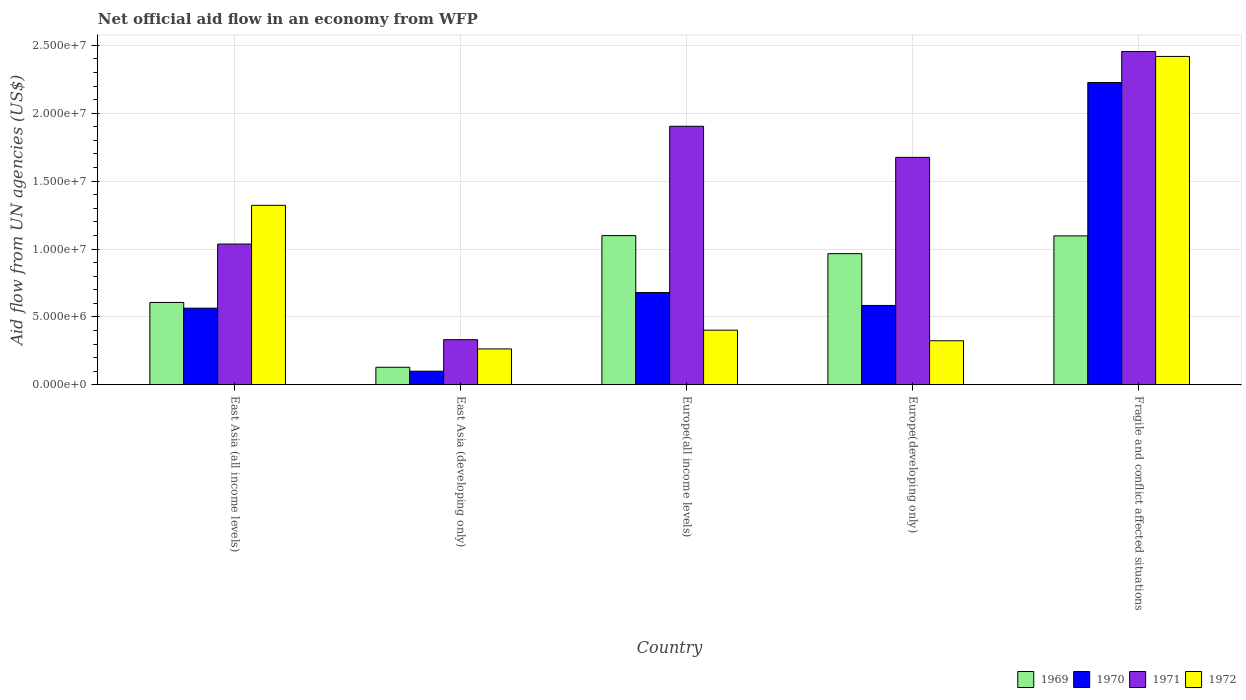How many groups of bars are there?
Your answer should be compact. 5. Are the number of bars per tick equal to the number of legend labels?
Provide a succinct answer. Yes. Are the number of bars on each tick of the X-axis equal?
Provide a short and direct response. Yes. What is the label of the 5th group of bars from the left?
Provide a succinct answer. Fragile and conflict affected situations. What is the net official aid flow in 1971 in Fragile and conflict affected situations?
Ensure brevity in your answer.  2.45e+07. Across all countries, what is the maximum net official aid flow in 1971?
Provide a succinct answer. 2.45e+07. Across all countries, what is the minimum net official aid flow in 1972?
Offer a terse response. 2.65e+06. In which country was the net official aid flow in 1971 maximum?
Provide a short and direct response. Fragile and conflict affected situations. In which country was the net official aid flow in 1971 minimum?
Keep it short and to the point. East Asia (developing only). What is the total net official aid flow in 1970 in the graph?
Your answer should be very brief. 4.16e+07. What is the difference between the net official aid flow in 1971 in East Asia (all income levels) and that in Europe(all income levels)?
Keep it short and to the point. -8.67e+06. What is the difference between the net official aid flow in 1972 in Europe(developing only) and the net official aid flow in 1970 in East Asia (developing only)?
Ensure brevity in your answer.  2.24e+06. What is the average net official aid flow in 1971 per country?
Give a very brief answer. 1.48e+07. What is the difference between the net official aid flow of/in 1970 and net official aid flow of/in 1972 in Fragile and conflict affected situations?
Keep it short and to the point. -1.92e+06. In how many countries, is the net official aid flow in 1969 greater than 8000000 US$?
Give a very brief answer. 3. What is the ratio of the net official aid flow in 1971 in Europe(all income levels) to that in Fragile and conflict affected situations?
Offer a terse response. 0.78. Is the difference between the net official aid flow in 1970 in East Asia (developing only) and Europe(all income levels) greater than the difference between the net official aid flow in 1972 in East Asia (developing only) and Europe(all income levels)?
Ensure brevity in your answer.  No. What is the difference between the highest and the second highest net official aid flow in 1971?
Your response must be concise. 5.50e+06. What is the difference between the highest and the lowest net official aid flow in 1971?
Give a very brief answer. 2.12e+07. In how many countries, is the net official aid flow in 1969 greater than the average net official aid flow in 1969 taken over all countries?
Your response must be concise. 3. Is it the case that in every country, the sum of the net official aid flow in 1971 and net official aid flow in 1972 is greater than the sum of net official aid flow in 1970 and net official aid flow in 1969?
Keep it short and to the point. No. What does the 4th bar from the right in East Asia (all income levels) represents?
Provide a succinct answer. 1969. Are all the bars in the graph horizontal?
Provide a succinct answer. No. How many countries are there in the graph?
Offer a very short reply. 5. Where does the legend appear in the graph?
Make the answer very short. Bottom right. What is the title of the graph?
Make the answer very short. Net official aid flow in an economy from WFP. Does "1987" appear as one of the legend labels in the graph?
Give a very brief answer. No. What is the label or title of the Y-axis?
Your answer should be compact. Aid flow from UN agencies (US$). What is the Aid flow from UN agencies (US$) of 1969 in East Asia (all income levels)?
Make the answer very short. 6.07e+06. What is the Aid flow from UN agencies (US$) in 1970 in East Asia (all income levels)?
Your answer should be compact. 5.65e+06. What is the Aid flow from UN agencies (US$) in 1971 in East Asia (all income levels)?
Offer a very short reply. 1.04e+07. What is the Aid flow from UN agencies (US$) of 1972 in East Asia (all income levels)?
Your answer should be very brief. 1.32e+07. What is the Aid flow from UN agencies (US$) in 1969 in East Asia (developing only)?
Offer a terse response. 1.30e+06. What is the Aid flow from UN agencies (US$) of 1970 in East Asia (developing only)?
Give a very brief answer. 1.01e+06. What is the Aid flow from UN agencies (US$) in 1971 in East Asia (developing only)?
Provide a short and direct response. 3.33e+06. What is the Aid flow from UN agencies (US$) in 1972 in East Asia (developing only)?
Your answer should be compact. 2.65e+06. What is the Aid flow from UN agencies (US$) in 1969 in Europe(all income levels)?
Your answer should be compact. 1.10e+07. What is the Aid flow from UN agencies (US$) of 1970 in Europe(all income levels)?
Give a very brief answer. 6.80e+06. What is the Aid flow from UN agencies (US$) of 1971 in Europe(all income levels)?
Provide a short and direct response. 1.90e+07. What is the Aid flow from UN agencies (US$) of 1972 in Europe(all income levels)?
Offer a terse response. 4.03e+06. What is the Aid flow from UN agencies (US$) in 1969 in Europe(developing only)?
Your answer should be very brief. 9.66e+06. What is the Aid flow from UN agencies (US$) in 1970 in Europe(developing only)?
Make the answer very short. 5.85e+06. What is the Aid flow from UN agencies (US$) in 1971 in Europe(developing only)?
Provide a succinct answer. 1.68e+07. What is the Aid flow from UN agencies (US$) in 1972 in Europe(developing only)?
Provide a succinct answer. 3.25e+06. What is the Aid flow from UN agencies (US$) in 1969 in Fragile and conflict affected situations?
Give a very brief answer. 1.10e+07. What is the Aid flow from UN agencies (US$) of 1970 in Fragile and conflict affected situations?
Keep it short and to the point. 2.23e+07. What is the Aid flow from UN agencies (US$) in 1971 in Fragile and conflict affected situations?
Your answer should be very brief. 2.45e+07. What is the Aid flow from UN agencies (US$) of 1972 in Fragile and conflict affected situations?
Offer a terse response. 2.42e+07. Across all countries, what is the maximum Aid flow from UN agencies (US$) in 1969?
Provide a short and direct response. 1.10e+07. Across all countries, what is the maximum Aid flow from UN agencies (US$) of 1970?
Provide a succinct answer. 2.23e+07. Across all countries, what is the maximum Aid flow from UN agencies (US$) of 1971?
Offer a very short reply. 2.45e+07. Across all countries, what is the maximum Aid flow from UN agencies (US$) in 1972?
Offer a terse response. 2.42e+07. Across all countries, what is the minimum Aid flow from UN agencies (US$) in 1969?
Provide a short and direct response. 1.30e+06. Across all countries, what is the minimum Aid flow from UN agencies (US$) of 1970?
Keep it short and to the point. 1.01e+06. Across all countries, what is the minimum Aid flow from UN agencies (US$) in 1971?
Your answer should be very brief. 3.33e+06. Across all countries, what is the minimum Aid flow from UN agencies (US$) of 1972?
Offer a terse response. 2.65e+06. What is the total Aid flow from UN agencies (US$) in 1969 in the graph?
Make the answer very short. 3.90e+07. What is the total Aid flow from UN agencies (US$) in 1970 in the graph?
Ensure brevity in your answer.  4.16e+07. What is the total Aid flow from UN agencies (US$) in 1971 in the graph?
Your answer should be very brief. 7.40e+07. What is the total Aid flow from UN agencies (US$) of 1972 in the graph?
Offer a very short reply. 4.73e+07. What is the difference between the Aid flow from UN agencies (US$) in 1969 in East Asia (all income levels) and that in East Asia (developing only)?
Your answer should be very brief. 4.77e+06. What is the difference between the Aid flow from UN agencies (US$) in 1970 in East Asia (all income levels) and that in East Asia (developing only)?
Keep it short and to the point. 4.64e+06. What is the difference between the Aid flow from UN agencies (US$) of 1971 in East Asia (all income levels) and that in East Asia (developing only)?
Provide a succinct answer. 7.04e+06. What is the difference between the Aid flow from UN agencies (US$) of 1972 in East Asia (all income levels) and that in East Asia (developing only)?
Your answer should be compact. 1.06e+07. What is the difference between the Aid flow from UN agencies (US$) in 1969 in East Asia (all income levels) and that in Europe(all income levels)?
Offer a terse response. -4.92e+06. What is the difference between the Aid flow from UN agencies (US$) in 1970 in East Asia (all income levels) and that in Europe(all income levels)?
Keep it short and to the point. -1.15e+06. What is the difference between the Aid flow from UN agencies (US$) in 1971 in East Asia (all income levels) and that in Europe(all income levels)?
Ensure brevity in your answer.  -8.67e+06. What is the difference between the Aid flow from UN agencies (US$) of 1972 in East Asia (all income levels) and that in Europe(all income levels)?
Your response must be concise. 9.19e+06. What is the difference between the Aid flow from UN agencies (US$) in 1969 in East Asia (all income levels) and that in Europe(developing only)?
Keep it short and to the point. -3.59e+06. What is the difference between the Aid flow from UN agencies (US$) of 1971 in East Asia (all income levels) and that in Europe(developing only)?
Make the answer very short. -6.38e+06. What is the difference between the Aid flow from UN agencies (US$) in 1972 in East Asia (all income levels) and that in Europe(developing only)?
Provide a succinct answer. 9.97e+06. What is the difference between the Aid flow from UN agencies (US$) of 1969 in East Asia (all income levels) and that in Fragile and conflict affected situations?
Provide a short and direct response. -4.90e+06. What is the difference between the Aid flow from UN agencies (US$) of 1970 in East Asia (all income levels) and that in Fragile and conflict affected situations?
Your answer should be very brief. -1.66e+07. What is the difference between the Aid flow from UN agencies (US$) in 1971 in East Asia (all income levels) and that in Fragile and conflict affected situations?
Offer a very short reply. -1.42e+07. What is the difference between the Aid flow from UN agencies (US$) in 1972 in East Asia (all income levels) and that in Fragile and conflict affected situations?
Your answer should be very brief. -1.10e+07. What is the difference between the Aid flow from UN agencies (US$) in 1969 in East Asia (developing only) and that in Europe(all income levels)?
Make the answer very short. -9.69e+06. What is the difference between the Aid flow from UN agencies (US$) in 1970 in East Asia (developing only) and that in Europe(all income levels)?
Provide a short and direct response. -5.79e+06. What is the difference between the Aid flow from UN agencies (US$) of 1971 in East Asia (developing only) and that in Europe(all income levels)?
Keep it short and to the point. -1.57e+07. What is the difference between the Aid flow from UN agencies (US$) in 1972 in East Asia (developing only) and that in Europe(all income levels)?
Offer a very short reply. -1.38e+06. What is the difference between the Aid flow from UN agencies (US$) of 1969 in East Asia (developing only) and that in Europe(developing only)?
Ensure brevity in your answer.  -8.36e+06. What is the difference between the Aid flow from UN agencies (US$) in 1970 in East Asia (developing only) and that in Europe(developing only)?
Make the answer very short. -4.84e+06. What is the difference between the Aid flow from UN agencies (US$) in 1971 in East Asia (developing only) and that in Europe(developing only)?
Offer a very short reply. -1.34e+07. What is the difference between the Aid flow from UN agencies (US$) of 1972 in East Asia (developing only) and that in Europe(developing only)?
Your response must be concise. -6.00e+05. What is the difference between the Aid flow from UN agencies (US$) in 1969 in East Asia (developing only) and that in Fragile and conflict affected situations?
Give a very brief answer. -9.67e+06. What is the difference between the Aid flow from UN agencies (US$) of 1970 in East Asia (developing only) and that in Fragile and conflict affected situations?
Provide a short and direct response. -2.12e+07. What is the difference between the Aid flow from UN agencies (US$) of 1971 in East Asia (developing only) and that in Fragile and conflict affected situations?
Provide a short and direct response. -2.12e+07. What is the difference between the Aid flow from UN agencies (US$) of 1972 in East Asia (developing only) and that in Fragile and conflict affected situations?
Your answer should be compact. -2.15e+07. What is the difference between the Aid flow from UN agencies (US$) in 1969 in Europe(all income levels) and that in Europe(developing only)?
Give a very brief answer. 1.33e+06. What is the difference between the Aid flow from UN agencies (US$) of 1970 in Europe(all income levels) and that in Europe(developing only)?
Provide a short and direct response. 9.50e+05. What is the difference between the Aid flow from UN agencies (US$) of 1971 in Europe(all income levels) and that in Europe(developing only)?
Ensure brevity in your answer.  2.29e+06. What is the difference between the Aid flow from UN agencies (US$) in 1972 in Europe(all income levels) and that in Europe(developing only)?
Your answer should be very brief. 7.80e+05. What is the difference between the Aid flow from UN agencies (US$) of 1970 in Europe(all income levels) and that in Fragile and conflict affected situations?
Provide a short and direct response. -1.55e+07. What is the difference between the Aid flow from UN agencies (US$) of 1971 in Europe(all income levels) and that in Fragile and conflict affected situations?
Provide a succinct answer. -5.50e+06. What is the difference between the Aid flow from UN agencies (US$) of 1972 in Europe(all income levels) and that in Fragile and conflict affected situations?
Keep it short and to the point. -2.02e+07. What is the difference between the Aid flow from UN agencies (US$) of 1969 in Europe(developing only) and that in Fragile and conflict affected situations?
Provide a short and direct response. -1.31e+06. What is the difference between the Aid flow from UN agencies (US$) of 1970 in Europe(developing only) and that in Fragile and conflict affected situations?
Ensure brevity in your answer.  -1.64e+07. What is the difference between the Aid flow from UN agencies (US$) in 1971 in Europe(developing only) and that in Fragile and conflict affected situations?
Ensure brevity in your answer.  -7.79e+06. What is the difference between the Aid flow from UN agencies (US$) of 1972 in Europe(developing only) and that in Fragile and conflict affected situations?
Make the answer very short. -2.09e+07. What is the difference between the Aid flow from UN agencies (US$) of 1969 in East Asia (all income levels) and the Aid flow from UN agencies (US$) of 1970 in East Asia (developing only)?
Provide a succinct answer. 5.06e+06. What is the difference between the Aid flow from UN agencies (US$) of 1969 in East Asia (all income levels) and the Aid flow from UN agencies (US$) of 1971 in East Asia (developing only)?
Give a very brief answer. 2.74e+06. What is the difference between the Aid flow from UN agencies (US$) in 1969 in East Asia (all income levels) and the Aid flow from UN agencies (US$) in 1972 in East Asia (developing only)?
Keep it short and to the point. 3.42e+06. What is the difference between the Aid flow from UN agencies (US$) of 1970 in East Asia (all income levels) and the Aid flow from UN agencies (US$) of 1971 in East Asia (developing only)?
Your answer should be compact. 2.32e+06. What is the difference between the Aid flow from UN agencies (US$) of 1970 in East Asia (all income levels) and the Aid flow from UN agencies (US$) of 1972 in East Asia (developing only)?
Your response must be concise. 3.00e+06. What is the difference between the Aid flow from UN agencies (US$) in 1971 in East Asia (all income levels) and the Aid flow from UN agencies (US$) in 1972 in East Asia (developing only)?
Provide a succinct answer. 7.72e+06. What is the difference between the Aid flow from UN agencies (US$) of 1969 in East Asia (all income levels) and the Aid flow from UN agencies (US$) of 1970 in Europe(all income levels)?
Your response must be concise. -7.30e+05. What is the difference between the Aid flow from UN agencies (US$) of 1969 in East Asia (all income levels) and the Aid flow from UN agencies (US$) of 1971 in Europe(all income levels)?
Keep it short and to the point. -1.30e+07. What is the difference between the Aid flow from UN agencies (US$) in 1969 in East Asia (all income levels) and the Aid flow from UN agencies (US$) in 1972 in Europe(all income levels)?
Offer a terse response. 2.04e+06. What is the difference between the Aid flow from UN agencies (US$) in 1970 in East Asia (all income levels) and the Aid flow from UN agencies (US$) in 1971 in Europe(all income levels)?
Offer a very short reply. -1.34e+07. What is the difference between the Aid flow from UN agencies (US$) of 1970 in East Asia (all income levels) and the Aid flow from UN agencies (US$) of 1972 in Europe(all income levels)?
Give a very brief answer. 1.62e+06. What is the difference between the Aid flow from UN agencies (US$) of 1971 in East Asia (all income levels) and the Aid flow from UN agencies (US$) of 1972 in Europe(all income levels)?
Offer a terse response. 6.34e+06. What is the difference between the Aid flow from UN agencies (US$) of 1969 in East Asia (all income levels) and the Aid flow from UN agencies (US$) of 1970 in Europe(developing only)?
Ensure brevity in your answer.  2.20e+05. What is the difference between the Aid flow from UN agencies (US$) of 1969 in East Asia (all income levels) and the Aid flow from UN agencies (US$) of 1971 in Europe(developing only)?
Provide a succinct answer. -1.07e+07. What is the difference between the Aid flow from UN agencies (US$) of 1969 in East Asia (all income levels) and the Aid flow from UN agencies (US$) of 1972 in Europe(developing only)?
Your answer should be very brief. 2.82e+06. What is the difference between the Aid flow from UN agencies (US$) of 1970 in East Asia (all income levels) and the Aid flow from UN agencies (US$) of 1971 in Europe(developing only)?
Make the answer very short. -1.11e+07. What is the difference between the Aid flow from UN agencies (US$) of 1970 in East Asia (all income levels) and the Aid flow from UN agencies (US$) of 1972 in Europe(developing only)?
Give a very brief answer. 2.40e+06. What is the difference between the Aid flow from UN agencies (US$) of 1971 in East Asia (all income levels) and the Aid flow from UN agencies (US$) of 1972 in Europe(developing only)?
Your answer should be very brief. 7.12e+06. What is the difference between the Aid flow from UN agencies (US$) in 1969 in East Asia (all income levels) and the Aid flow from UN agencies (US$) in 1970 in Fragile and conflict affected situations?
Offer a terse response. -1.62e+07. What is the difference between the Aid flow from UN agencies (US$) of 1969 in East Asia (all income levels) and the Aid flow from UN agencies (US$) of 1971 in Fragile and conflict affected situations?
Ensure brevity in your answer.  -1.85e+07. What is the difference between the Aid flow from UN agencies (US$) in 1969 in East Asia (all income levels) and the Aid flow from UN agencies (US$) in 1972 in Fragile and conflict affected situations?
Your response must be concise. -1.81e+07. What is the difference between the Aid flow from UN agencies (US$) in 1970 in East Asia (all income levels) and the Aid flow from UN agencies (US$) in 1971 in Fragile and conflict affected situations?
Your response must be concise. -1.89e+07. What is the difference between the Aid flow from UN agencies (US$) of 1970 in East Asia (all income levels) and the Aid flow from UN agencies (US$) of 1972 in Fragile and conflict affected situations?
Offer a very short reply. -1.85e+07. What is the difference between the Aid flow from UN agencies (US$) of 1971 in East Asia (all income levels) and the Aid flow from UN agencies (US$) of 1972 in Fragile and conflict affected situations?
Your response must be concise. -1.38e+07. What is the difference between the Aid flow from UN agencies (US$) of 1969 in East Asia (developing only) and the Aid flow from UN agencies (US$) of 1970 in Europe(all income levels)?
Your answer should be compact. -5.50e+06. What is the difference between the Aid flow from UN agencies (US$) of 1969 in East Asia (developing only) and the Aid flow from UN agencies (US$) of 1971 in Europe(all income levels)?
Provide a succinct answer. -1.77e+07. What is the difference between the Aid flow from UN agencies (US$) of 1969 in East Asia (developing only) and the Aid flow from UN agencies (US$) of 1972 in Europe(all income levels)?
Your response must be concise. -2.73e+06. What is the difference between the Aid flow from UN agencies (US$) in 1970 in East Asia (developing only) and the Aid flow from UN agencies (US$) in 1971 in Europe(all income levels)?
Ensure brevity in your answer.  -1.80e+07. What is the difference between the Aid flow from UN agencies (US$) of 1970 in East Asia (developing only) and the Aid flow from UN agencies (US$) of 1972 in Europe(all income levels)?
Keep it short and to the point. -3.02e+06. What is the difference between the Aid flow from UN agencies (US$) of 1971 in East Asia (developing only) and the Aid flow from UN agencies (US$) of 1972 in Europe(all income levels)?
Give a very brief answer. -7.00e+05. What is the difference between the Aid flow from UN agencies (US$) in 1969 in East Asia (developing only) and the Aid flow from UN agencies (US$) in 1970 in Europe(developing only)?
Offer a very short reply. -4.55e+06. What is the difference between the Aid flow from UN agencies (US$) of 1969 in East Asia (developing only) and the Aid flow from UN agencies (US$) of 1971 in Europe(developing only)?
Provide a succinct answer. -1.54e+07. What is the difference between the Aid flow from UN agencies (US$) in 1969 in East Asia (developing only) and the Aid flow from UN agencies (US$) in 1972 in Europe(developing only)?
Provide a succinct answer. -1.95e+06. What is the difference between the Aid flow from UN agencies (US$) of 1970 in East Asia (developing only) and the Aid flow from UN agencies (US$) of 1971 in Europe(developing only)?
Your response must be concise. -1.57e+07. What is the difference between the Aid flow from UN agencies (US$) of 1970 in East Asia (developing only) and the Aid flow from UN agencies (US$) of 1972 in Europe(developing only)?
Offer a very short reply. -2.24e+06. What is the difference between the Aid flow from UN agencies (US$) of 1971 in East Asia (developing only) and the Aid flow from UN agencies (US$) of 1972 in Europe(developing only)?
Your answer should be very brief. 8.00e+04. What is the difference between the Aid flow from UN agencies (US$) in 1969 in East Asia (developing only) and the Aid flow from UN agencies (US$) in 1970 in Fragile and conflict affected situations?
Provide a succinct answer. -2.10e+07. What is the difference between the Aid flow from UN agencies (US$) in 1969 in East Asia (developing only) and the Aid flow from UN agencies (US$) in 1971 in Fragile and conflict affected situations?
Ensure brevity in your answer.  -2.32e+07. What is the difference between the Aid flow from UN agencies (US$) in 1969 in East Asia (developing only) and the Aid flow from UN agencies (US$) in 1972 in Fragile and conflict affected situations?
Your response must be concise. -2.29e+07. What is the difference between the Aid flow from UN agencies (US$) of 1970 in East Asia (developing only) and the Aid flow from UN agencies (US$) of 1971 in Fragile and conflict affected situations?
Provide a succinct answer. -2.35e+07. What is the difference between the Aid flow from UN agencies (US$) in 1970 in East Asia (developing only) and the Aid flow from UN agencies (US$) in 1972 in Fragile and conflict affected situations?
Offer a very short reply. -2.32e+07. What is the difference between the Aid flow from UN agencies (US$) in 1971 in East Asia (developing only) and the Aid flow from UN agencies (US$) in 1972 in Fragile and conflict affected situations?
Your answer should be very brief. -2.08e+07. What is the difference between the Aid flow from UN agencies (US$) of 1969 in Europe(all income levels) and the Aid flow from UN agencies (US$) of 1970 in Europe(developing only)?
Provide a succinct answer. 5.14e+06. What is the difference between the Aid flow from UN agencies (US$) of 1969 in Europe(all income levels) and the Aid flow from UN agencies (US$) of 1971 in Europe(developing only)?
Keep it short and to the point. -5.76e+06. What is the difference between the Aid flow from UN agencies (US$) in 1969 in Europe(all income levels) and the Aid flow from UN agencies (US$) in 1972 in Europe(developing only)?
Keep it short and to the point. 7.74e+06. What is the difference between the Aid flow from UN agencies (US$) of 1970 in Europe(all income levels) and the Aid flow from UN agencies (US$) of 1971 in Europe(developing only)?
Make the answer very short. -9.95e+06. What is the difference between the Aid flow from UN agencies (US$) in 1970 in Europe(all income levels) and the Aid flow from UN agencies (US$) in 1972 in Europe(developing only)?
Provide a succinct answer. 3.55e+06. What is the difference between the Aid flow from UN agencies (US$) in 1971 in Europe(all income levels) and the Aid flow from UN agencies (US$) in 1972 in Europe(developing only)?
Provide a short and direct response. 1.58e+07. What is the difference between the Aid flow from UN agencies (US$) in 1969 in Europe(all income levels) and the Aid flow from UN agencies (US$) in 1970 in Fragile and conflict affected situations?
Your response must be concise. -1.13e+07. What is the difference between the Aid flow from UN agencies (US$) of 1969 in Europe(all income levels) and the Aid flow from UN agencies (US$) of 1971 in Fragile and conflict affected situations?
Provide a succinct answer. -1.36e+07. What is the difference between the Aid flow from UN agencies (US$) of 1969 in Europe(all income levels) and the Aid flow from UN agencies (US$) of 1972 in Fragile and conflict affected situations?
Your answer should be very brief. -1.32e+07. What is the difference between the Aid flow from UN agencies (US$) in 1970 in Europe(all income levels) and the Aid flow from UN agencies (US$) in 1971 in Fragile and conflict affected situations?
Provide a succinct answer. -1.77e+07. What is the difference between the Aid flow from UN agencies (US$) of 1970 in Europe(all income levels) and the Aid flow from UN agencies (US$) of 1972 in Fragile and conflict affected situations?
Provide a short and direct response. -1.74e+07. What is the difference between the Aid flow from UN agencies (US$) of 1971 in Europe(all income levels) and the Aid flow from UN agencies (US$) of 1972 in Fragile and conflict affected situations?
Your answer should be compact. -5.14e+06. What is the difference between the Aid flow from UN agencies (US$) of 1969 in Europe(developing only) and the Aid flow from UN agencies (US$) of 1970 in Fragile and conflict affected situations?
Offer a terse response. -1.26e+07. What is the difference between the Aid flow from UN agencies (US$) of 1969 in Europe(developing only) and the Aid flow from UN agencies (US$) of 1971 in Fragile and conflict affected situations?
Provide a succinct answer. -1.49e+07. What is the difference between the Aid flow from UN agencies (US$) of 1969 in Europe(developing only) and the Aid flow from UN agencies (US$) of 1972 in Fragile and conflict affected situations?
Your answer should be very brief. -1.45e+07. What is the difference between the Aid flow from UN agencies (US$) of 1970 in Europe(developing only) and the Aid flow from UN agencies (US$) of 1971 in Fragile and conflict affected situations?
Provide a succinct answer. -1.87e+07. What is the difference between the Aid flow from UN agencies (US$) of 1970 in Europe(developing only) and the Aid flow from UN agencies (US$) of 1972 in Fragile and conflict affected situations?
Your response must be concise. -1.83e+07. What is the difference between the Aid flow from UN agencies (US$) of 1971 in Europe(developing only) and the Aid flow from UN agencies (US$) of 1972 in Fragile and conflict affected situations?
Ensure brevity in your answer.  -7.43e+06. What is the average Aid flow from UN agencies (US$) of 1969 per country?
Make the answer very short. 7.80e+06. What is the average Aid flow from UN agencies (US$) in 1970 per country?
Make the answer very short. 8.31e+06. What is the average Aid flow from UN agencies (US$) of 1971 per country?
Make the answer very short. 1.48e+07. What is the average Aid flow from UN agencies (US$) of 1972 per country?
Your answer should be very brief. 9.47e+06. What is the difference between the Aid flow from UN agencies (US$) in 1969 and Aid flow from UN agencies (US$) in 1970 in East Asia (all income levels)?
Provide a short and direct response. 4.20e+05. What is the difference between the Aid flow from UN agencies (US$) in 1969 and Aid flow from UN agencies (US$) in 1971 in East Asia (all income levels)?
Offer a very short reply. -4.30e+06. What is the difference between the Aid flow from UN agencies (US$) of 1969 and Aid flow from UN agencies (US$) of 1972 in East Asia (all income levels)?
Make the answer very short. -7.15e+06. What is the difference between the Aid flow from UN agencies (US$) in 1970 and Aid flow from UN agencies (US$) in 1971 in East Asia (all income levels)?
Ensure brevity in your answer.  -4.72e+06. What is the difference between the Aid flow from UN agencies (US$) in 1970 and Aid flow from UN agencies (US$) in 1972 in East Asia (all income levels)?
Provide a succinct answer. -7.57e+06. What is the difference between the Aid flow from UN agencies (US$) in 1971 and Aid flow from UN agencies (US$) in 1972 in East Asia (all income levels)?
Offer a very short reply. -2.85e+06. What is the difference between the Aid flow from UN agencies (US$) in 1969 and Aid flow from UN agencies (US$) in 1970 in East Asia (developing only)?
Your answer should be compact. 2.90e+05. What is the difference between the Aid flow from UN agencies (US$) in 1969 and Aid flow from UN agencies (US$) in 1971 in East Asia (developing only)?
Offer a very short reply. -2.03e+06. What is the difference between the Aid flow from UN agencies (US$) of 1969 and Aid flow from UN agencies (US$) of 1972 in East Asia (developing only)?
Give a very brief answer. -1.35e+06. What is the difference between the Aid flow from UN agencies (US$) in 1970 and Aid flow from UN agencies (US$) in 1971 in East Asia (developing only)?
Offer a very short reply. -2.32e+06. What is the difference between the Aid flow from UN agencies (US$) in 1970 and Aid flow from UN agencies (US$) in 1972 in East Asia (developing only)?
Offer a very short reply. -1.64e+06. What is the difference between the Aid flow from UN agencies (US$) in 1971 and Aid flow from UN agencies (US$) in 1972 in East Asia (developing only)?
Make the answer very short. 6.80e+05. What is the difference between the Aid flow from UN agencies (US$) of 1969 and Aid flow from UN agencies (US$) of 1970 in Europe(all income levels)?
Ensure brevity in your answer.  4.19e+06. What is the difference between the Aid flow from UN agencies (US$) in 1969 and Aid flow from UN agencies (US$) in 1971 in Europe(all income levels)?
Provide a short and direct response. -8.05e+06. What is the difference between the Aid flow from UN agencies (US$) in 1969 and Aid flow from UN agencies (US$) in 1972 in Europe(all income levels)?
Give a very brief answer. 6.96e+06. What is the difference between the Aid flow from UN agencies (US$) in 1970 and Aid flow from UN agencies (US$) in 1971 in Europe(all income levels)?
Provide a succinct answer. -1.22e+07. What is the difference between the Aid flow from UN agencies (US$) in 1970 and Aid flow from UN agencies (US$) in 1972 in Europe(all income levels)?
Your answer should be compact. 2.77e+06. What is the difference between the Aid flow from UN agencies (US$) in 1971 and Aid flow from UN agencies (US$) in 1972 in Europe(all income levels)?
Provide a short and direct response. 1.50e+07. What is the difference between the Aid flow from UN agencies (US$) in 1969 and Aid flow from UN agencies (US$) in 1970 in Europe(developing only)?
Ensure brevity in your answer.  3.81e+06. What is the difference between the Aid flow from UN agencies (US$) of 1969 and Aid flow from UN agencies (US$) of 1971 in Europe(developing only)?
Your answer should be very brief. -7.09e+06. What is the difference between the Aid flow from UN agencies (US$) of 1969 and Aid flow from UN agencies (US$) of 1972 in Europe(developing only)?
Provide a succinct answer. 6.41e+06. What is the difference between the Aid flow from UN agencies (US$) of 1970 and Aid flow from UN agencies (US$) of 1971 in Europe(developing only)?
Ensure brevity in your answer.  -1.09e+07. What is the difference between the Aid flow from UN agencies (US$) in 1970 and Aid flow from UN agencies (US$) in 1972 in Europe(developing only)?
Your answer should be very brief. 2.60e+06. What is the difference between the Aid flow from UN agencies (US$) of 1971 and Aid flow from UN agencies (US$) of 1972 in Europe(developing only)?
Your response must be concise. 1.35e+07. What is the difference between the Aid flow from UN agencies (US$) in 1969 and Aid flow from UN agencies (US$) in 1970 in Fragile and conflict affected situations?
Keep it short and to the point. -1.13e+07. What is the difference between the Aid flow from UN agencies (US$) of 1969 and Aid flow from UN agencies (US$) of 1971 in Fragile and conflict affected situations?
Provide a short and direct response. -1.36e+07. What is the difference between the Aid flow from UN agencies (US$) in 1969 and Aid flow from UN agencies (US$) in 1972 in Fragile and conflict affected situations?
Provide a short and direct response. -1.32e+07. What is the difference between the Aid flow from UN agencies (US$) of 1970 and Aid flow from UN agencies (US$) of 1971 in Fragile and conflict affected situations?
Provide a succinct answer. -2.28e+06. What is the difference between the Aid flow from UN agencies (US$) in 1970 and Aid flow from UN agencies (US$) in 1972 in Fragile and conflict affected situations?
Offer a very short reply. -1.92e+06. What is the difference between the Aid flow from UN agencies (US$) of 1971 and Aid flow from UN agencies (US$) of 1972 in Fragile and conflict affected situations?
Offer a terse response. 3.60e+05. What is the ratio of the Aid flow from UN agencies (US$) of 1969 in East Asia (all income levels) to that in East Asia (developing only)?
Your response must be concise. 4.67. What is the ratio of the Aid flow from UN agencies (US$) in 1970 in East Asia (all income levels) to that in East Asia (developing only)?
Provide a succinct answer. 5.59. What is the ratio of the Aid flow from UN agencies (US$) of 1971 in East Asia (all income levels) to that in East Asia (developing only)?
Provide a succinct answer. 3.11. What is the ratio of the Aid flow from UN agencies (US$) in 1972 in East Asia (all income levels) to that in East Asia (developing only)?
Ensure brevity in your answer.  4.99. What is the ratio of the Aid flow from UN agencies (US$) in 1969 in East Asia (all income levels) to that in Europe(all income levels)?
Make the answer very short. 0.55. What is the ratio of the Aid flow from UN agencies (US$) of 1970 in East Asia (all income levels) to that in Europe(all income levels)?
Give a very brief answer. 0.83. What is the ratio of the Aid flow from UN agencies (US$) of 1971 in East Asia (all income levels) to that in Europe(all income levels)?
Offer a very short reply. 0.54. What is the ratio of the Aid flow from UN agencies (US$) of 1972 in East Asia (all income levels) to that in Europe(all income levels)?
Provide a succinct answer. 3.28. What is the ratio of the Aid flow from UN agencies (US$) of 1969 in East Asia (all income levels) to that in Europe(developing only)?
Provide a succinct answer. 0.63. What is the ratio of the Aid flow from UN agencies (US$) in 1970 in East Asia (all income levels) to that in Europe(developing only)?
Your answer should be compact. 0.97. What is the ratio of the Aid flow from UN agencies (US$) of 1971 in East Asia (all income levels) to that in Europe(developing only)?
Your answer should be compact. 0.62. What is the ratio of the Aid flow from UN agencies (US$) in 1972 in East Asia (all income levels) to that in Europe(developing only)?
Your answer should be compact. 4.07. What is the ratio of the Aid flow from UN agencies (US$) of 1969 in East Asia (all income levels) to that in Fragile and conflict affected situations?
Offer a very short reply. 0.55. What is the ratio of the Aid flow from UN agencies (US$) in 1970 in East Asia (all income levels) to that in Fragile and conflict affected situations?
Offer a very short reply. 0.25. What is the ratio of the Aid flow from UN agencies (US$) in 1971 in East Asia (all income levels) to that in Fragile and conflict affected situations?
Offer a terse response. 0.42. What is the ratio of the Aid flow from UN agencies (US$) of 1972 in East Asia (all income levels) to that in Fragile and conflict affected situations?
Give a very brief answer. 0.55. What is the ratio of the Aid flow from UN agencies (US$) in 1969 in East Asia (developing only) to that in Europe(all income levels)?
Make the answer very short. 0.12. What is the ratio of the Aid flow from UN agencies (US$) in 1970 in East Asia (developing only) to that in Europe(all income levels)?
Provide a short and direct response. 0.15. What is the ratio of the Aid flow from UN agencies (US$) in 1971 in East Asia (developing only) to that in Europe(all income levels)?
Provide a succinct answer. 0.17. What is the ratio of the Aid flow from UN agencies (US$) in 1972 in East Asia (developing only) to that in Europe(all income levels)?
Give a very brief answer. 0.66. What is the ratio of the Aid flow from UN agencies (US$) of 1969 in East Asia (developing only) to that in Europe(developing only)?
Your answer should be very brief. 0.13. What is the ratio of the Aid flow from UN agencies (US$) in 1970 in East Asia (developing only) to that in Europe(developing only)?
Offer a terse response. 0.17. What is the ratio of the Aid flow from UN agencies (US$) of 1971 in East Asia (developing only) to that in Europe(developing only)?
Offer a terse response. 0.2. What is the ratio of the Aid flow from UN agencies (US$) in 1972 in East Asia (developing only) to that in Europe(developing only)?
Offer a very short reply. 0.82. What is the ratio of the Aid flow from UN agencies (US$) in 1969 in East Asia (developing only) to that in Fragile and conflict affected situations?
Your answer should be very brief. 0.12. What is the ratio of the Aid flow from UN agencies (US$) in 1970 in East Asia (developing only) to that in Fragile and conflict affected situations?
Your response must be concise. 0.05. What is the ratio of the Aid flow from UN agencies (US$) of 1971 in East Asia (developing only) to that in Fragile and conflict affected situations?
Your answer should be very brief. 0.14. What is the ratio of the Aid flow from UN agencies (US$) of 1972 in East Asia (developing only) to that in Fragile and conflict affected situations?
Make the answer very short. 0.11. What is the ratio of the Aid flow from UN agencies (US$) in 1969 in Europe(all income levels) to that in Europe(developing only)?
Offer a terse response. 1.14. What is the ratio of the Aid flow from UN agencies (US$) in 1970 in Europe(all income levels) to that in Europe(developing only)?
Your answer should be compact. 1.16. What is the ratio of the Aid flow from UN agencies (US$) of 1971 in Europe(all income levels) to that in Europe(developing only)?
Provide a succinct answer. 1.14. What is the ratio of the Aid flow from UN agencies (US$) of 1972 in Europe(all income levels) to that in Europe(developing only)?
Offer a very short reply. 1.24. What is the ratio of the Aid flow from UN agencies (US$) in 1970 in Europe(all income levels) to that in Fragile and conflict affected situations?
Give a very brief answer. 0.31. What is the ratio of the Aid flow from UN agencies (US$) of 1971 in Europe(all income levels) to that in Fragile and conflict affected situations?
Ensure brevity in your answer.  0.78. What is the ratio of the Aid flow from UN agencies (US$) of 1969 in Europe(developing only) to that in Fragile and conflict affected situations?
Provide a succinct answer. 0.88. What is the ratio of the Aid flow from UN agencies (US$) of 1970 in Europe(developing only) to that in Fragile and conflict affected situations?
Provide a succinct answer. 0.26. What is the ratio of the Aid flow from UN agencies (US$) of 1971 in Europe(developing only) to that in Fragile and conflict affected situations?
Provide a short and direct response. 0.68. What is the ratio of the Aid flow from UN agencies (US$) in 1972 in Europe(developing only) to that in Fragile and conflict affected situations?
Provide a short and direct response. 0.13. What is the difference between the highest and the second highest Aid flow from UN agencies (US$) in 1969?
Give a very brief answer. 2.00e+04. What is the difference between the highest and the second highest Aid flow from UN agencies (US$) in 1970?
Ensure brevity in your answer.  1.55e+07. What is the difference between the highest and the second highest Aid flow from UN agencies (US$) of 1971?
Your answer should be compact. 5.50e+06. What is the difference between the highest and the second highest Aid flow from UN agencies (US$) of 1972?
Ensure brevity in your answer.  1.10e+07. What is the difference between the highest and the lowest Aid flow from UN agencies (US$) of 1969?
Make the answer very short. 9.69e+06. What is the difference between the highest and the lowest Aid flow from UN agencies (US$) in 1970?
Keep it short and to the point. 2.12e+07. What is the difference between the highest and the lowest Aid flow from UN agencies (US$) of 1971?
Make the answer very short. 2.12e+07. What is the difference between the highest and the lowest Aid flow from UN agencies (US$) of 1972?
Offer a terse response. 2.15e+07. 